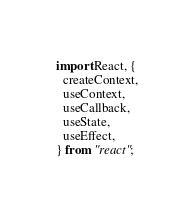Convert code to text. <code><loc_0><loc_0><loc_500><loc_500><_TypeScript_>import React, {
  createContext,
  useContext,
  useCallback,
  useState,
  useEffect,
} from "react";
</code> 